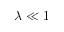<formula> <loc_0><loc_0><loc_500><loc_500>\lambda \ll 1</formula> 